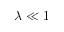<formula> <loc_0><loc_0><loc_500><loc_500>\lambda \ll 1</formula> 